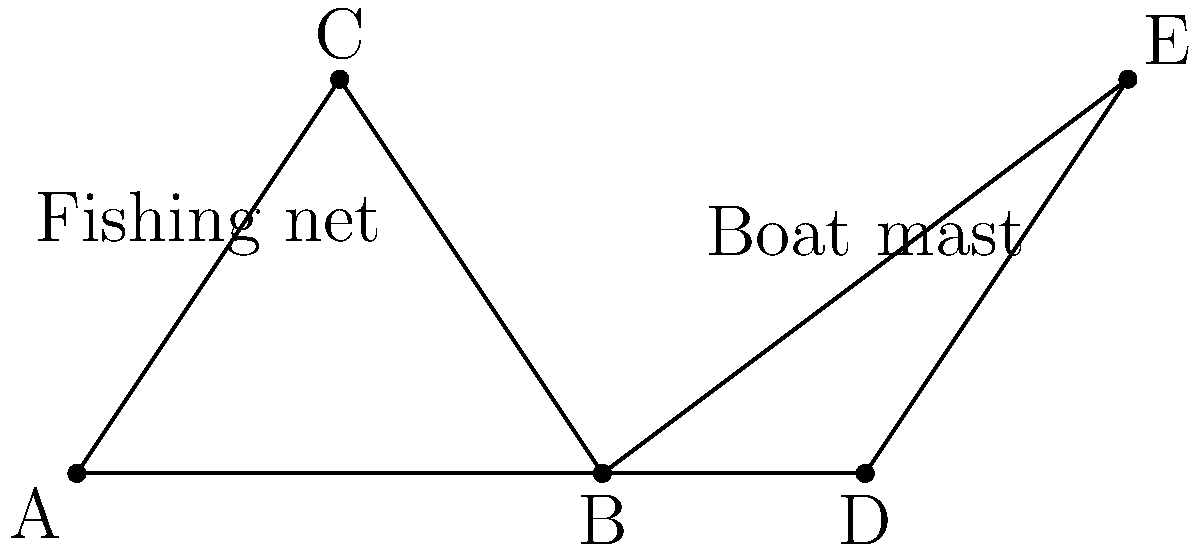In the diagram, two triangles are formed by fishing nets and boat masts. Triangle ABC represents a fishing net, while triangle BDE represents a boat's sail. If $\angle ABC = \angle DBE$ and $\overline{AB} = \overline{BD}$, what additional information is needed to prove that these triangles are congruent? To prove that two triangles are congruent, we need to use one of the congruence criteria. Let's analyze the given information and determine what's missing:

1. We know that $\angle ABC = \angle DBE$. This gives us one pair of congruent angles.

2. We're told that $\overline{AB} = \overline{BD}$. This provides us with one pair of congruent sides.

3. To use the Side-Angle-Side (SAS) congruence criterion, we need the included angle between these two sides to be congruent in both triangles. This would be $\angle BAC$ and $\angle BDE$.

4. For the Angle-Side-Angle (ASA) criterion, we would need another pair of congruent angles, specifically $\angle BAC$ and $\angle BDE$, or $\angle BCA$ and $\angle BED$.

5. For the Side-Side-Side (SSS) criterion, we would need two more pairs of congruent sides: $\overline{BC} = \overline{BE}$ and $\overline{AC} = \overline{DE}$.

Given the context of fishing nets and boat masts, the most practical information to obtain would be the measure of $\angle BAC$ and $\angle BDE$. If these angles are equal, we could use the SAS criterion to prove congruence.

Therefore, the additional information needed is the congruence of $\angle BAC$ and $\angle BDE$.
Answer: $\angle BAC = \angle BDE$ 